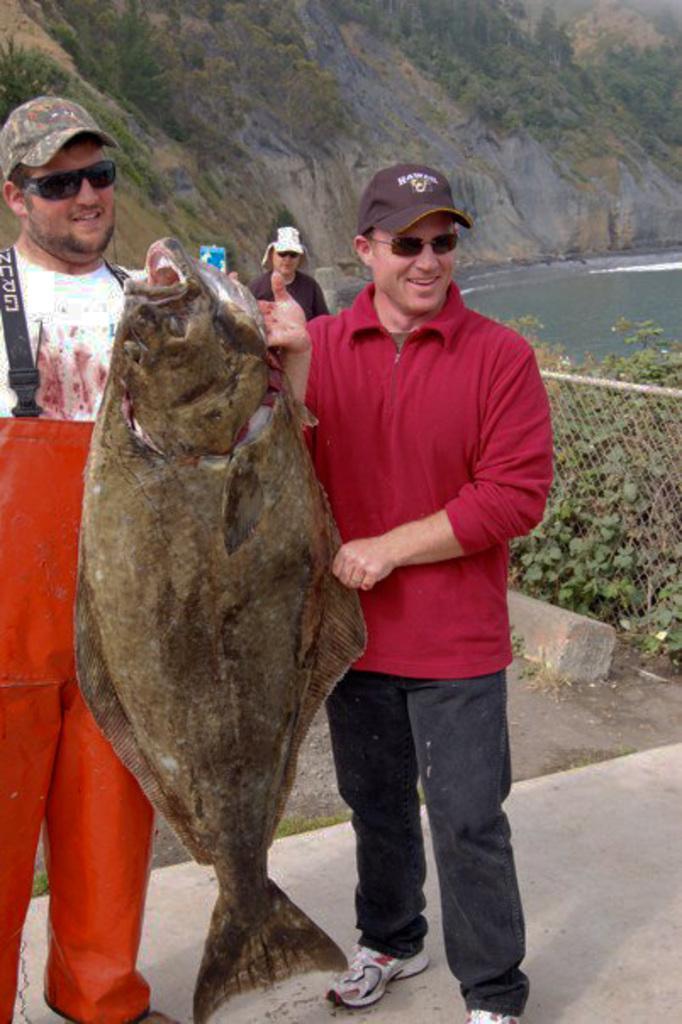Describe this image in one or two sentences. In the image we can see two people standing, wearing clothes, shoes, caps, goggles and they are smiling, they are holding fish. Here we can see the fence, plants, water and the hill. Behind them there is a person wearing clothes and cap. 